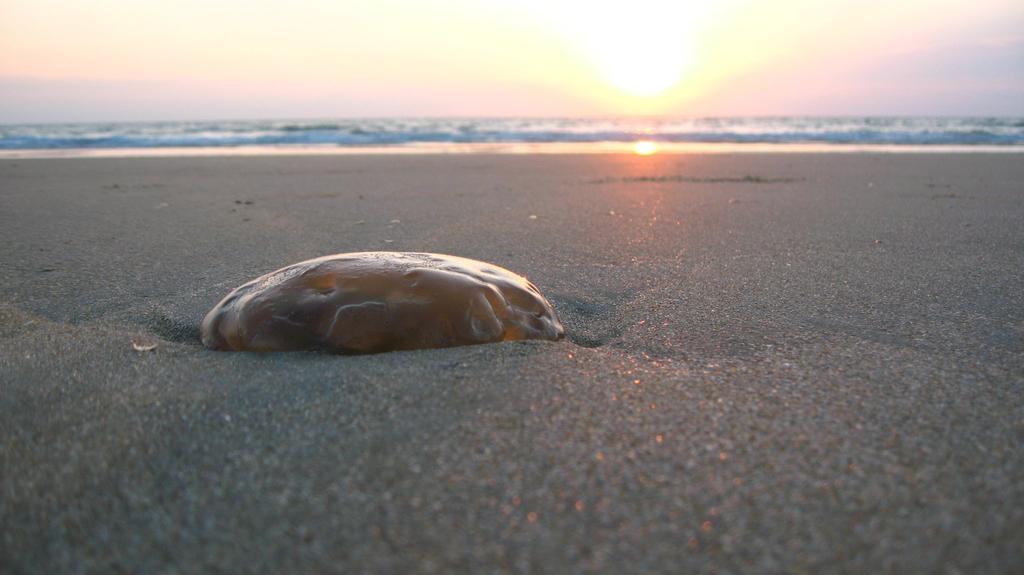How would you summarize this image in a sentence or two? In this picture there is an object on the sand and there is water in the background. 